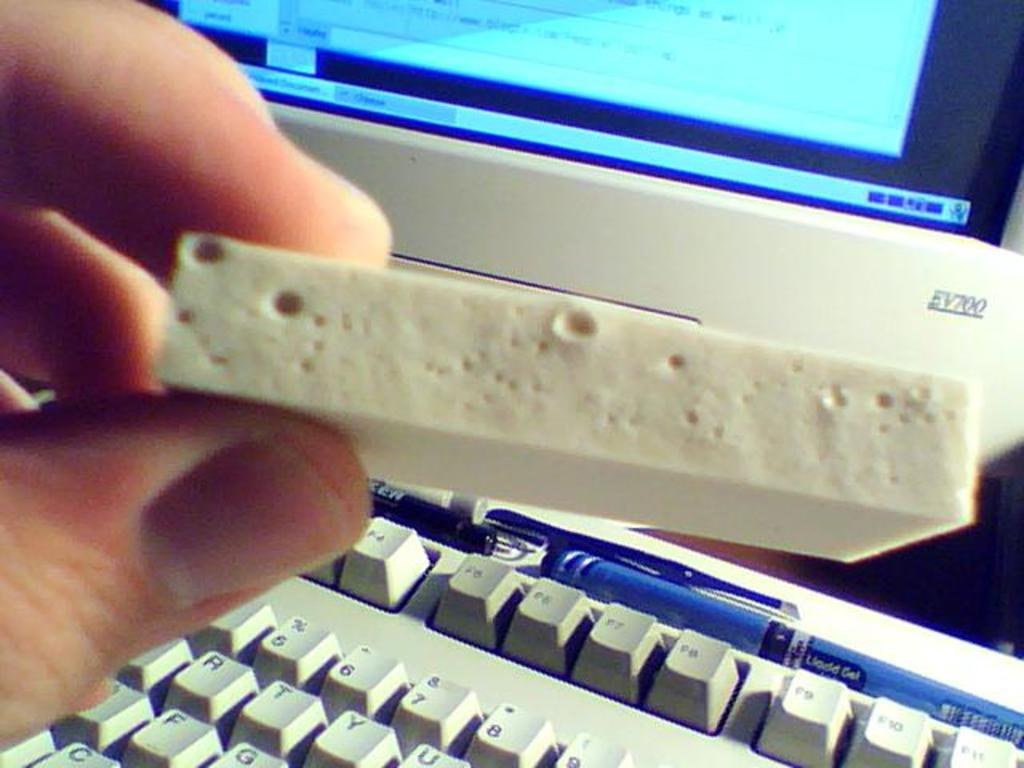<image>
Create a compact narrative representing the image presented. the monitor behind the man's hand has model number EV700 